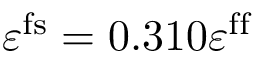Convert formula to latex. <formula><loc_0><loc_0><loc_500><loc_500>\varepsilon ^ { f s } = 0 . 3 1 0 \varepsilon ^ { f f }</formula> 